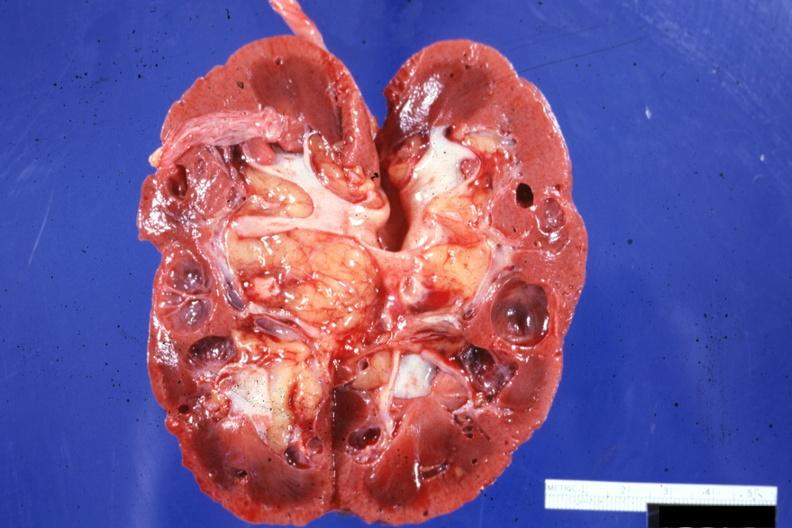what is present?
Answer the question using a single word or phrase. Multiple cysts 